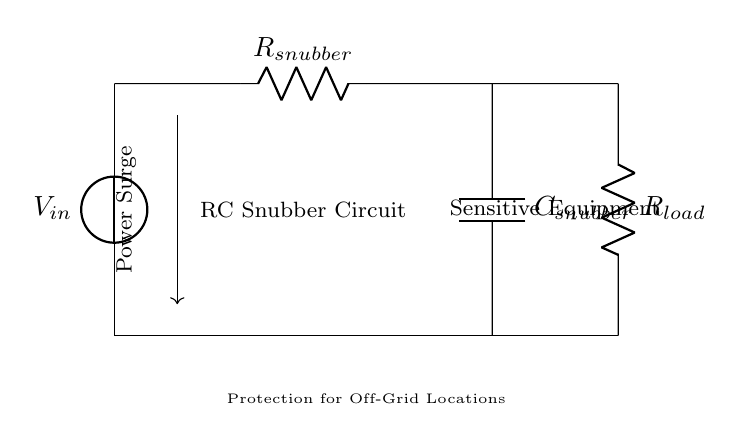What is the main purpose of the RC snubber circuit? The main purpose of the RC snubber circuit is to protect sensitive equipment from power surges, which could cause damage. The circuit acts to absorb and dissipate excess energy during voltage spikes.
Answer: Protection from power surges What components are present in the circuit? The components present in the circuit include two resistors (R), one capacitor (C), and a voltage source (V). These components work together to mitigate voltage spikes effectively.
Answer: Resistor, Capacitor, Voltage Source Where is the load resistor located? The load resistor is located at the bottom right of the circuit diagram, connected to the output alongside the snubber capacitor. Its placement indicates that it is part of the load that the circuit is protecting.
Answer: Bottom right What happens if the value of R snubber is increased? Increasing the value of R snubber will result in a slower discharge rate of the capacitor, which can enhance protection against surges but may also slow the response time of the snubber circuit. This is particularly important in transient conditions.
Answer: Slower discharge rate How does the circuit protect sensitive equipment from power surges? The circuit absorbs excess voltage from power surges through the resistor and capacitor combination, dissipating energy safely and preventing high voltage levels from reaching the sensitive equipment. The RC components work together to filter out temporary spikes in voltage.
Answer: Absorbs excess voltage What is the relationship between R snubber and C snubber in the circuit? The relationship between R snubber and C snubber is that they form an RC time constant that determines how quickly the circuit can respond to voltage changes. The combination of these components is essential for effective surge suppression.
Answer: Form RC time constant 